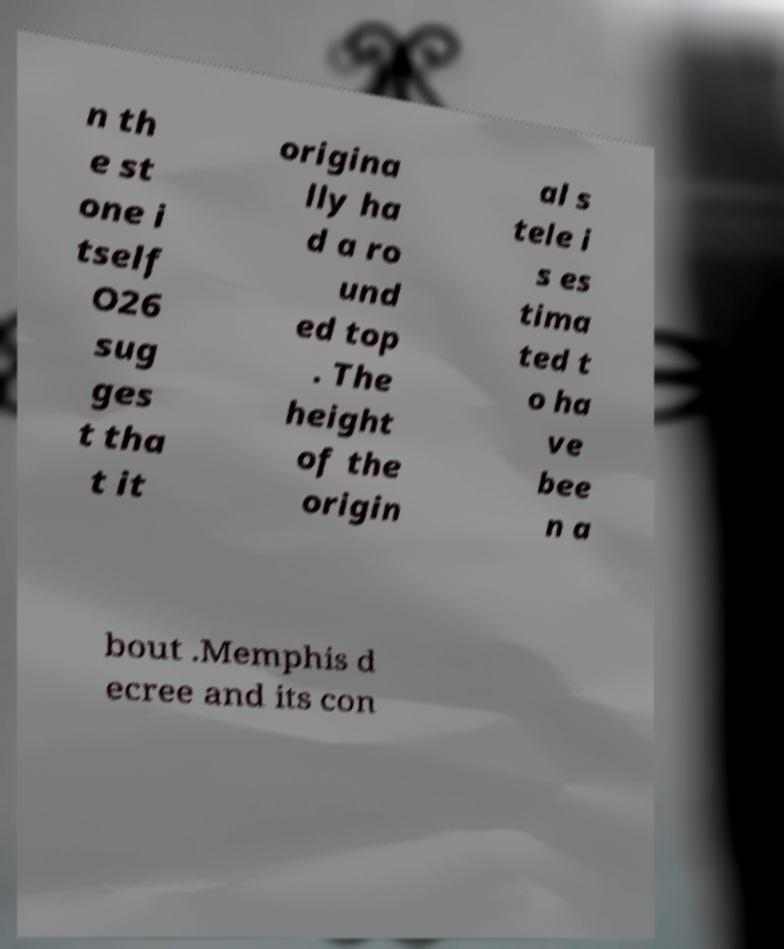There's text embedded in this image that I need extracted. Can you transcribe it verbatim? n th e st one i tself O26 sug ges t tha t it origina lly ha d a ro und ed top . The height of the origin al s tele i s es tima ted t o ha ve bee n a bout .Memphis d ecree and its con 